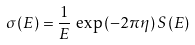Convert formula to latex. <formula><loc_0><loc_0><loc_500><loc_500>\sigma ( E ) = \frac { 1 } { E } \, \exp { ( - 2 \pi \eta ) } \, S ( E )</formula> 